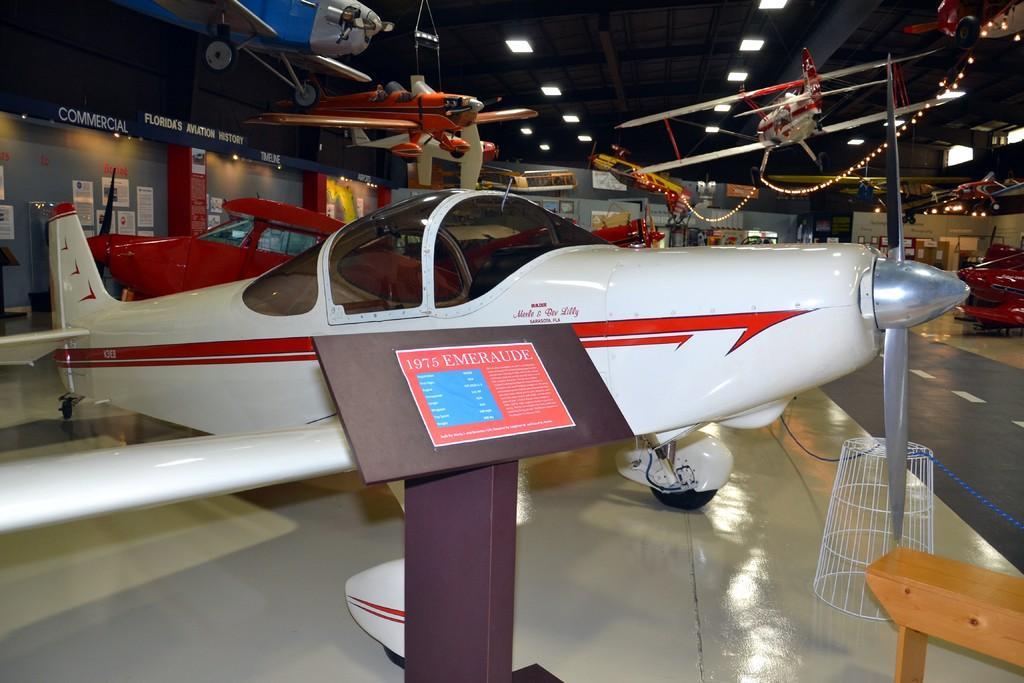Describe this image in one or two sentences. In this image I can see helicopters in a hall. In the background I can see a wall, boards and lights on a rooftop. This image is taken may be in a factory. 